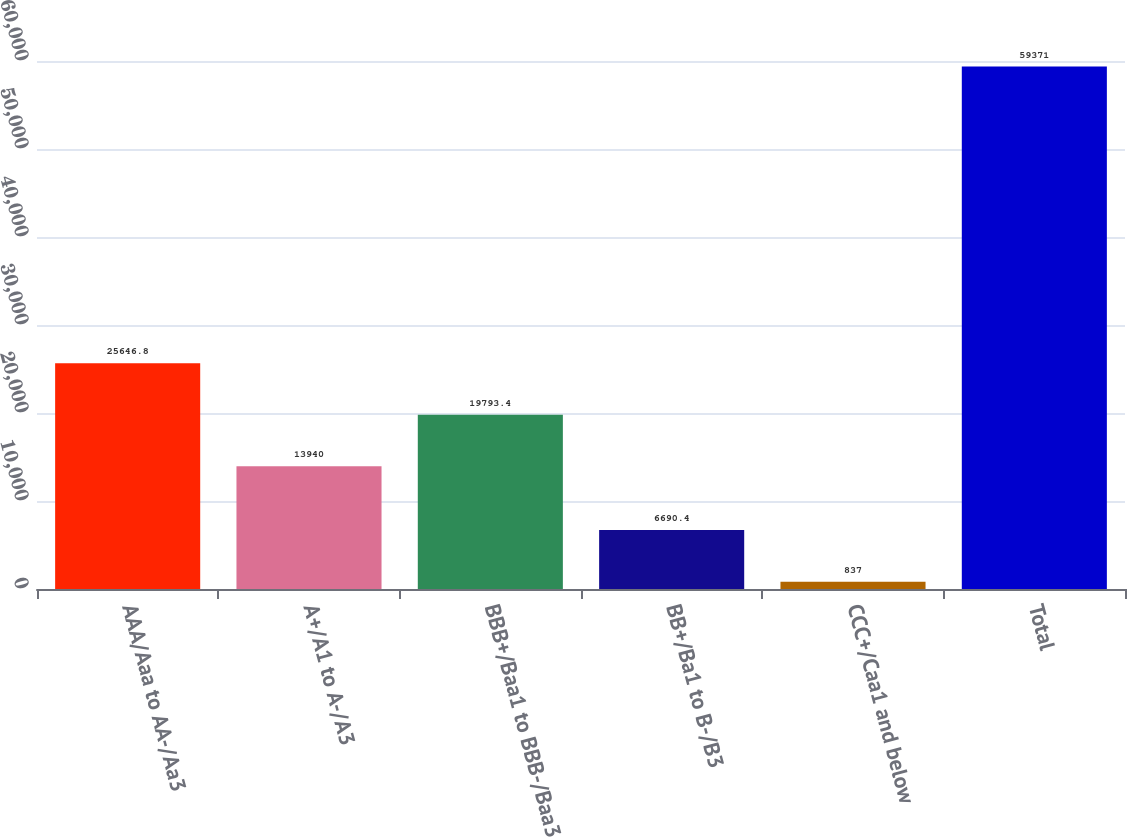Convert chart. <chart><loc_0><loc_0><loc_500><loc_500><bar_chart><fcel>AAA/Aaa to AA-/Aa3<fcel>A+/A1 to A-/A3<fcel>BBB+/Baa1 to BBB-/Baa3<fcel>BB+/Ba1 to B-/B3<fcel>CCC+/Caa1 and below<fcel>Total<nl><fcel>25646.8<fcel>13940<fcel>19793.4<fcel>6690.4<fcel>837<fcel>59371<nl></chart> 